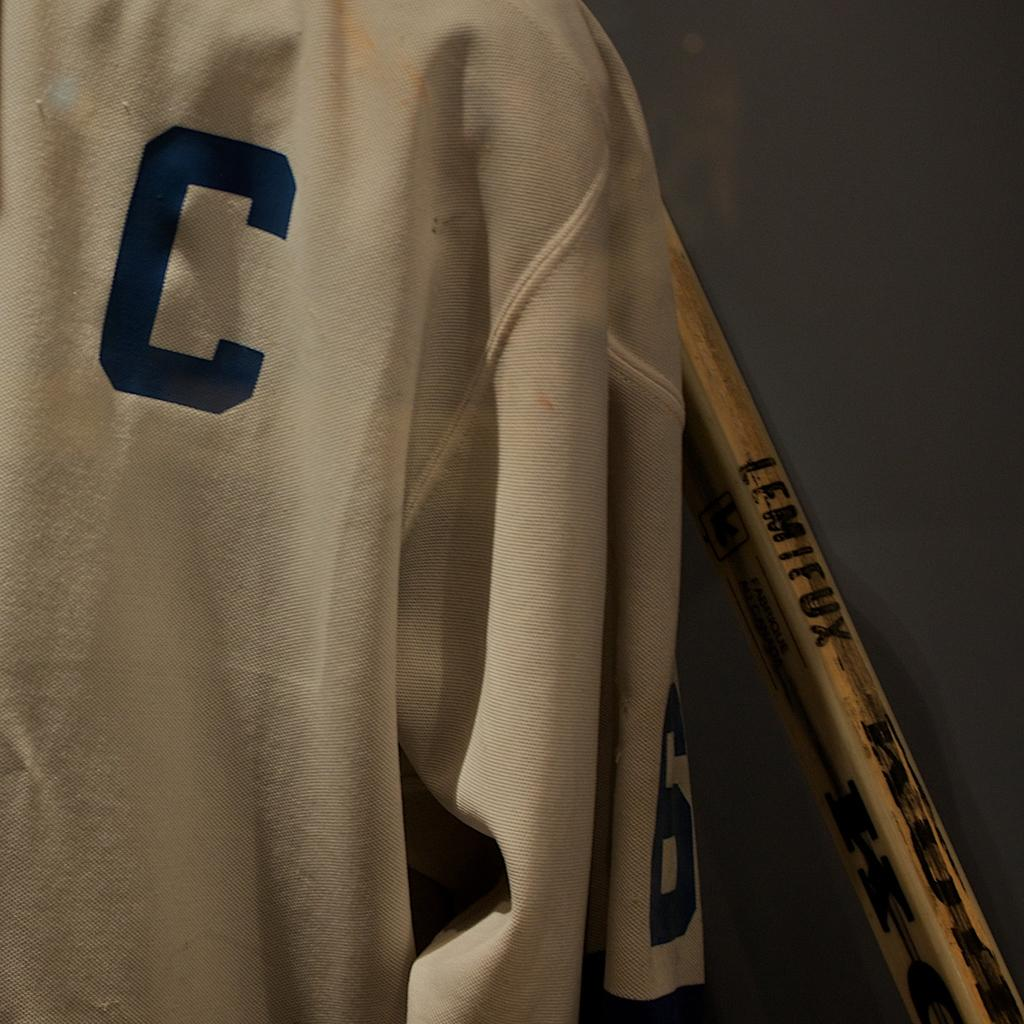<image>
Give a short and clear explanation of the subsequent image. The white top shown contains the letter C on the front. 